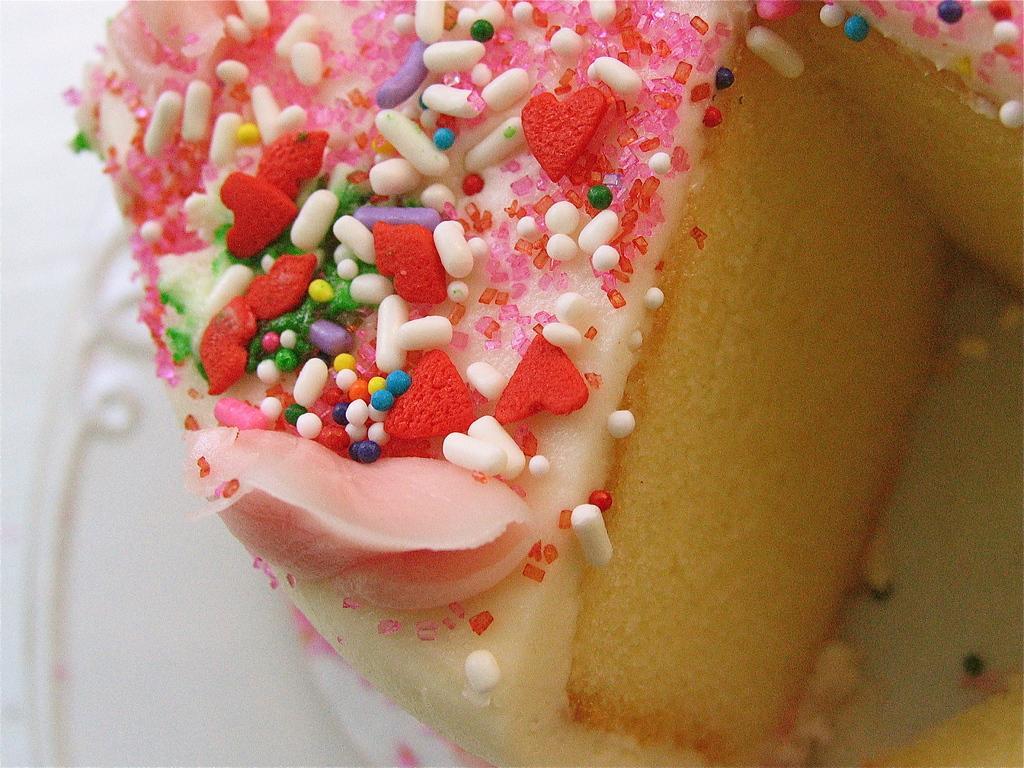Can you describe this image briefly? In this image I see a cake over here which is of white and light brown in color and I see ingredients on it which are of white, red, blue, yellow, orange, pink and violet in color and I see the white color thing in the background. 